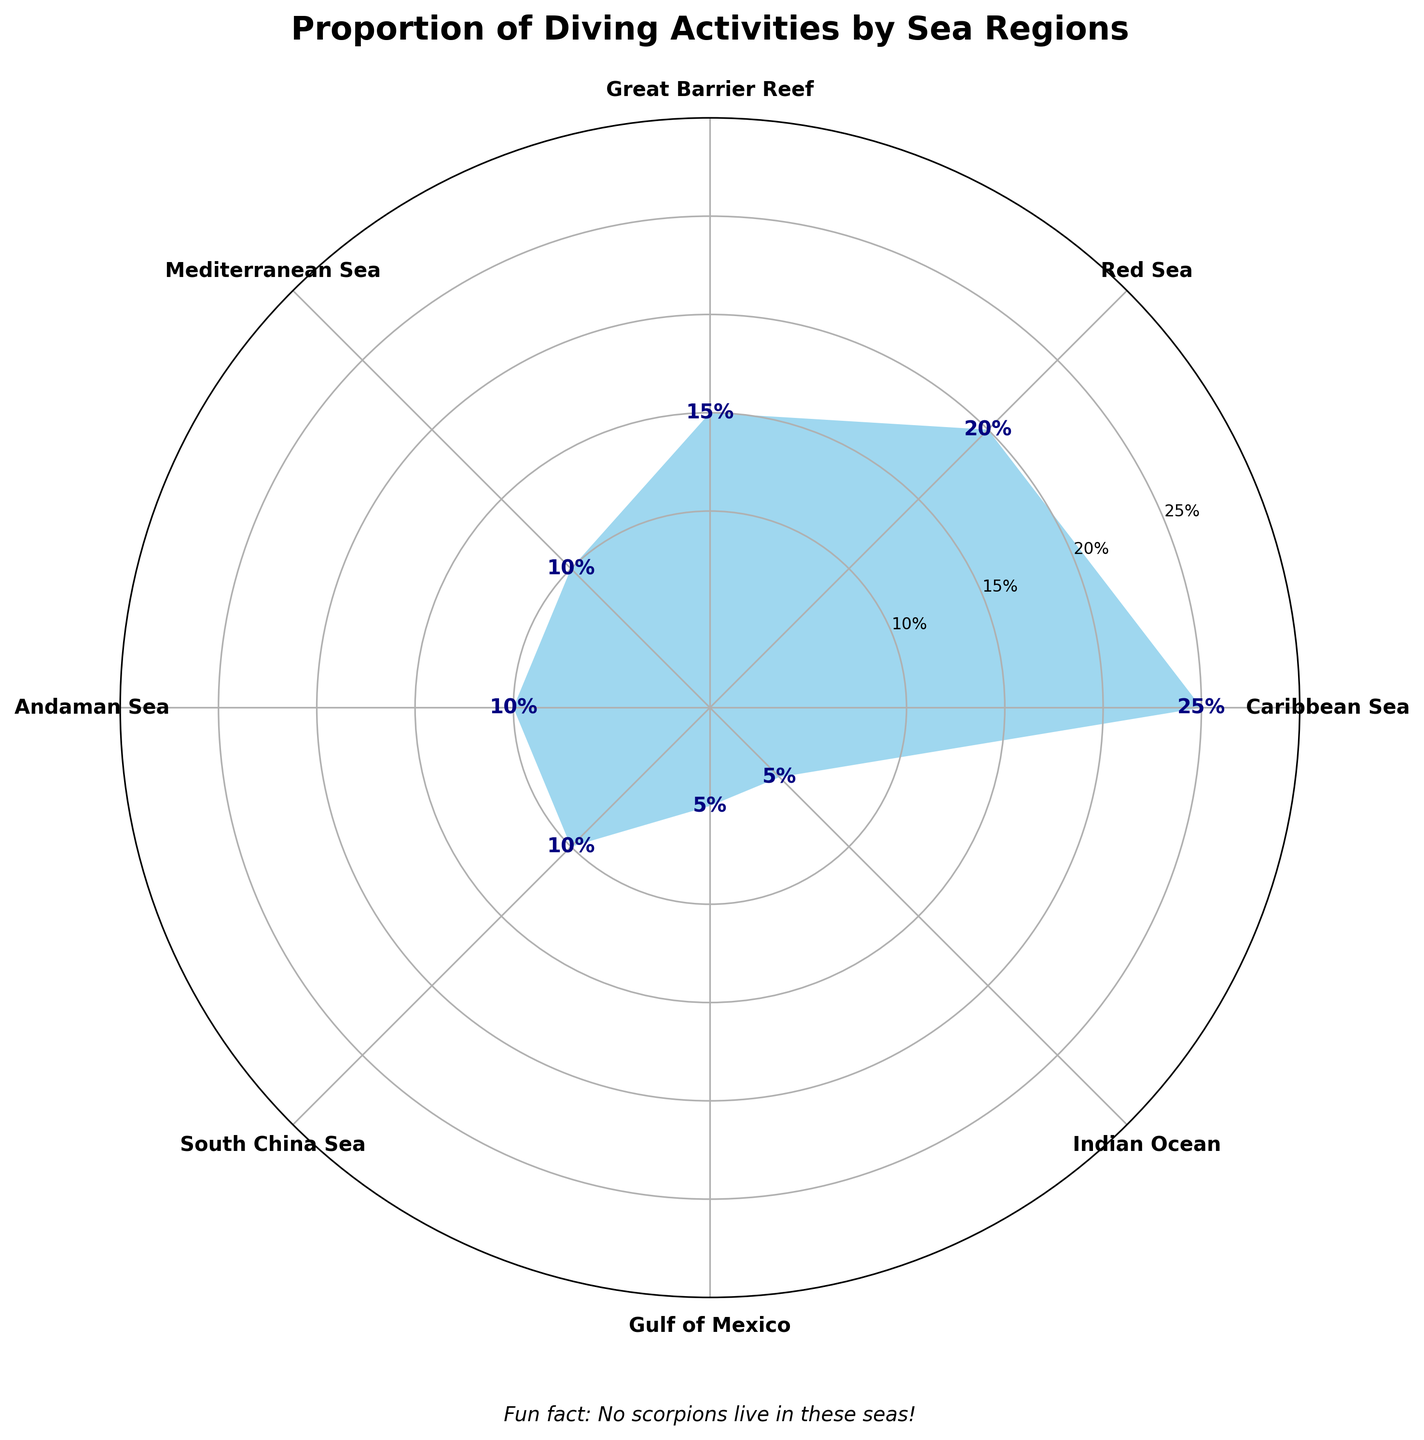What is the title of the polar area chart? The title is usually located at the top of the figure, written in larger and bold font for emphasis.
Answer: Proportion of Diving Activities by Sea Regions Which region has the highest proportion of diving activities? Look at the regions indicated on the outer edge of the polar area chart and check which segment extends the furthest from the center.
Answer: Caribbean Sea What is the combined proportion of diving activities in the Mediterranean Sea and Andaman Sea? Find the proportions for the Mediterranean Sea (0.10) and Andaman Sea (0.10) and sum them together (0.10 + 0.10).
Answer: 0.20 Which regions have the same proportion of diving activities? Identify regions with portions extending equally from the center of the polar chart.
Answer: Mediterranean Sea, Andaman Sea, South China Sea, Gulf of Mexico, Indian Ocean Does the Red Sea have a higher proportion of diving activities than the Great Barrier Reef? Look at the segments labeled "Red Sea" and "Great Barrier Reef" and compare their distances from the center.
Answer: Yes Rank the regions by their proportion of diving activities from highest to lowest. Observe the lengths of the segments from the center and order them accordingly.
Answer: Caribbean Sea, Red Sea, Great Barrier Reef, Mediterranean Sea, Andaman Sea, South China Sea, Gulf of Mexico, Indian Ocean How much more proportion of diving activities does the Caribbean Sea have compared to the Gulf of Mexico? Subtract the proportion of the Gulf of Mexico (0.05) from the proportion of the Caribbean Sea (0.25).
Answer: 0.20 What is the total proportion of diving activities in the South China Sea and the Indian Ocean? Sum the proportions of South China Sea (0.10) and Indian Ocean (0.05).
Answer: 0.15 Which region has the smallest proportion of diving activities? Find the region with the segment closest to the center.
Answer: Gulf of Mexico and Indian Ocean Is the proportion of diving activities in the South China Sea equal to that in the Mediterranean Sea? Compare the segments labeled "South China Sea" and "Mediterranean Sea".
Answer: Yes 